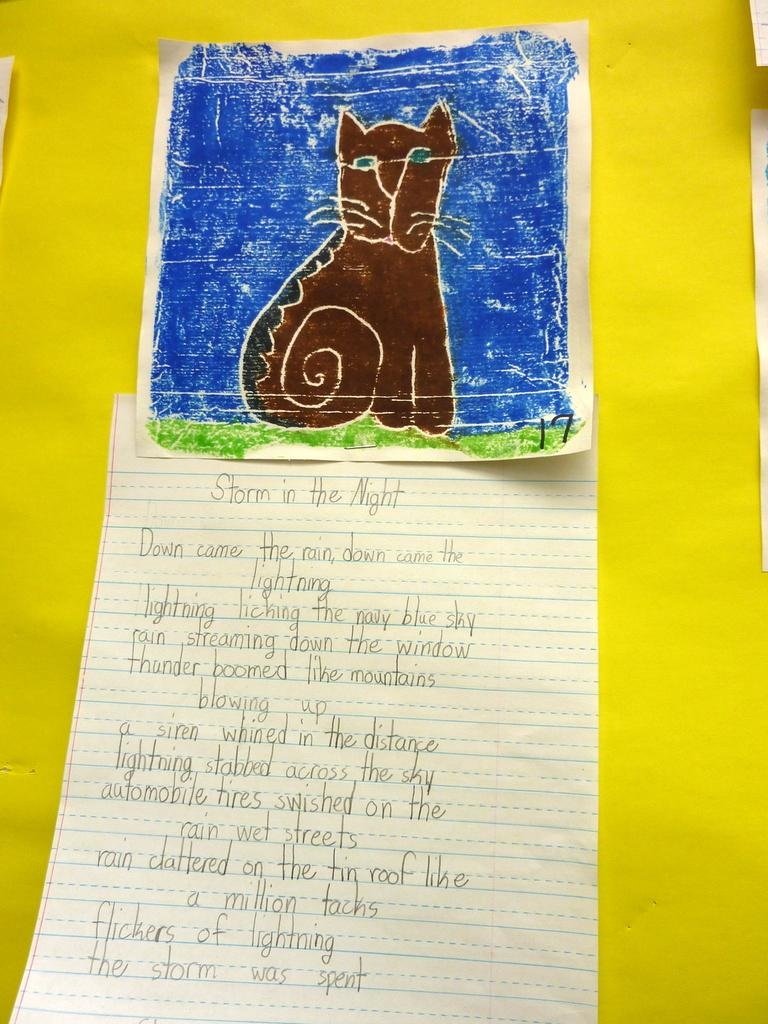What is depicted on the paper in the image? There is writing and a drawing on the paper. What is the color of the background in the image? The background color is yellow. Can you hear the whistle being blown in the image? There is no whistle present in the image, so it cannot be heard. 